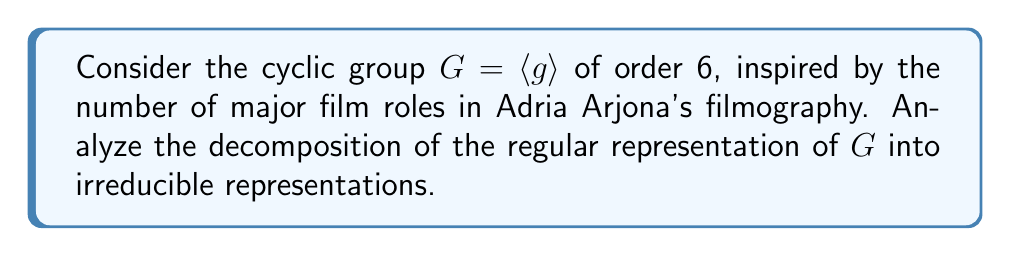Help me with this question. 1. The regular representation of a group $G$ has dimension $|G| = 6$.

2. For a cyclic group of order 6, there are 6 irreducible representations, each of dimension 1. These are given by:

   $\chi_k(g^j) = e^{2\pi i k j / 6}$, where $k = 0, 1, 2, 3, 4, 5$

3. The character of the regular representation $\rho_{reg}$ is:
   $$\chi_{reg}(g^j) = \begin{cases}
   6 & \text{if } j \equiv 0 \pmod{6} \\
   0 & \text{otherwise}
   \end{cases}$$

4. To decompose the regular representation, we need to find the multiplicity of each irreducible representation. The multiplicity $m_k$ of $\chi_k$ in $\rho_{reg}$ is given by:

   $$m_k = \frac{1}{|G|} \sum_{j=0}^5 \chi_{reg}(g^j) \overline{\chi_k(g^j)}$$

5. Calculating for each $k$:
   $$m_k = \frac{1}{6} (6 \cdot 1) = 1 \text{ for all } k$$

6. Therefore, the regular representation decomposes as:

   $$\rho_{reg} = \chi_0 \oplus \chi_1 \oplus \chi_2 \oplus \chi_3 \oplus \chi_4 \oplus \chi_5$$

This means that each irreducible representation appears exactly once in the decomposition of the regular representation.
Answer: $\rho_{reg} = \bigoplus_{k=0}^5 \chi_k$ 